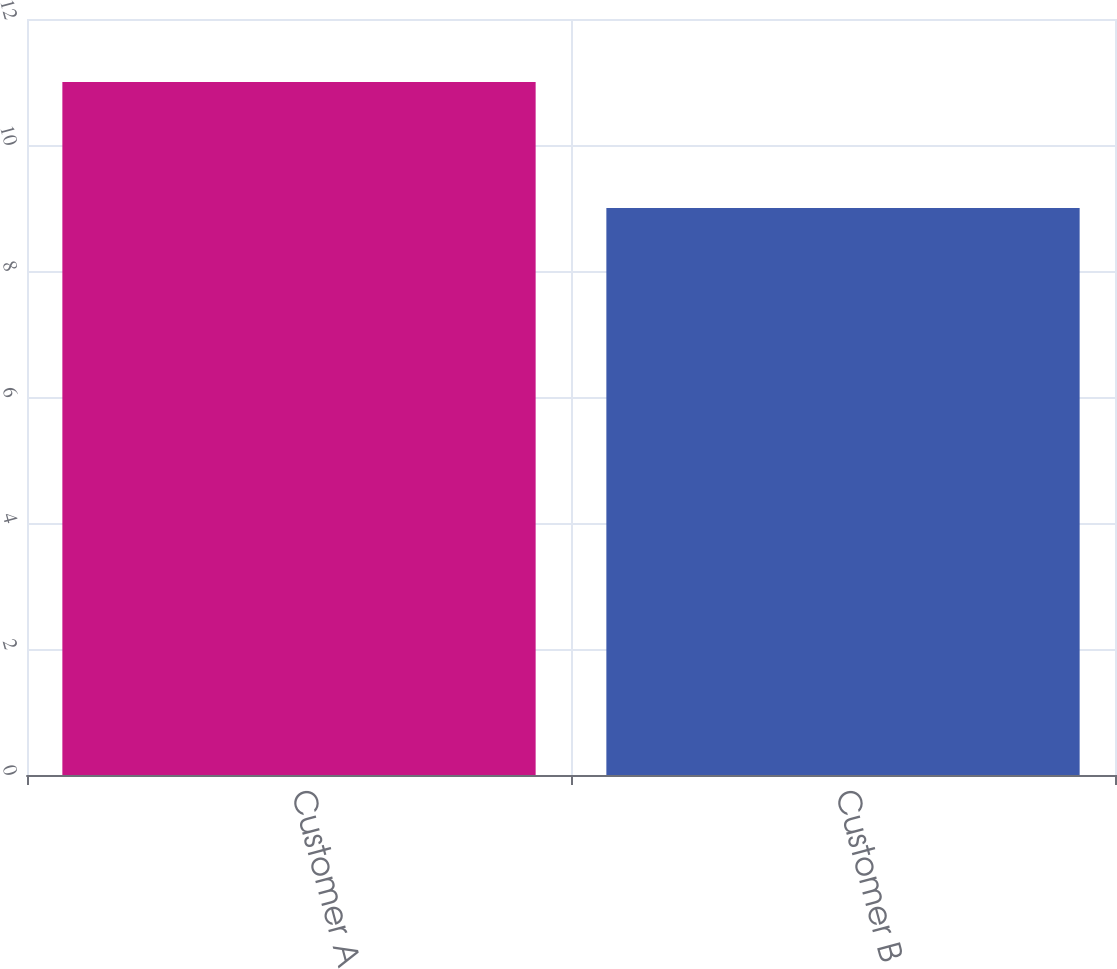<chart> <loc_0><loc_0><loc_500><loc_500><bar_chart><fcel>Customer A<fcel>Customer B<nl><fcel>11<fcel>9<nl></chart> 